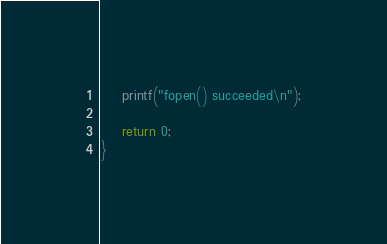<code> <loc_0><loc_0><loc_500><loc_500><_C_>    printf("fopen() succeeded\n");

    return 0;
}
</code> 